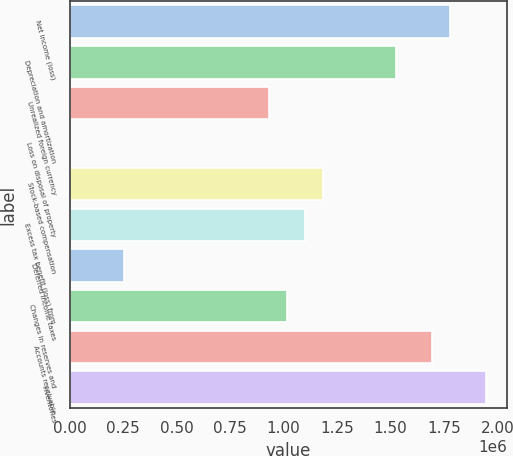Convert chart to OTSL. <chart><loc_0><loc_0><loc_500><loc_500><bar_chart><fcel>Net income (loss)<fcel>Depreciation and amortization<fcel>Unrealized foreign currency<fcel>Loss on disposal of property<fcel>Stock-based compensation<fcel>Excess tax benefit (loss) from<fcel>Deferred income taxes<fcel>Changes in reserves and<fcel>Accounts receivable<fcel>Inventories<nl><fcel>1.77909e+06<fcel>1.52502e+06<fcel>932168<fcel>549<fcel>1.18625e+06<fcel>1.10155e+06<fcel>254627<fcel>1.01686e+06<fcel>1.6944e+06<fcel>1.94848e+06<nl></chart> 